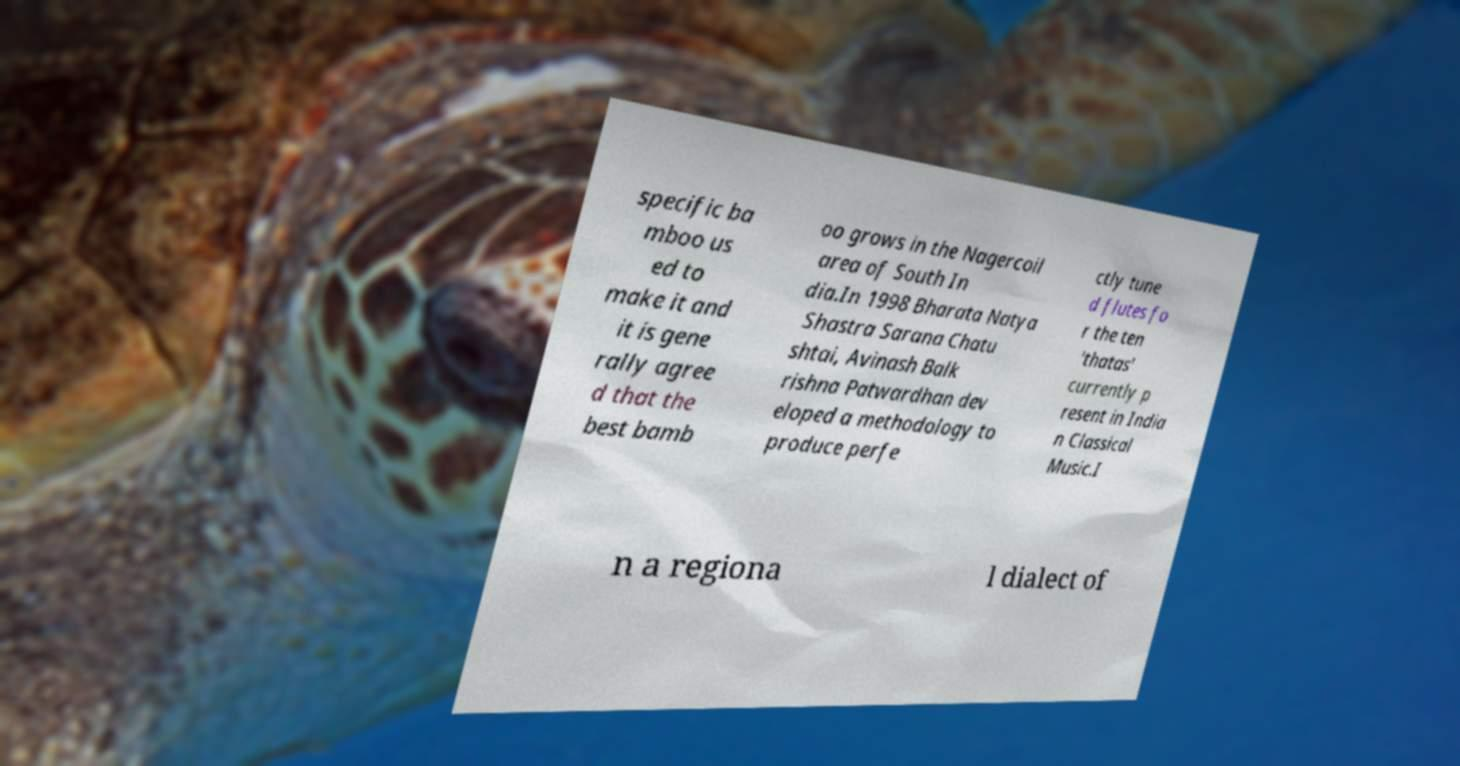There's text embedded in this image that I need extracted. Can you transcribe it verbatim? specific ba mboo us ed to make it and it is gene rally agree d that the best bamb oo grows in the Nagercoil area of South In dia.In 1998 Bharata Natya Shastra Sarana Chatu shtai, Avinash Balk rishna Patwardhan dev eloped a methodology to produce perfe ctly tune d flutes fo r the ten 'thatas' currently p resent in India n Classical Music.I n a regiona l dialect of 